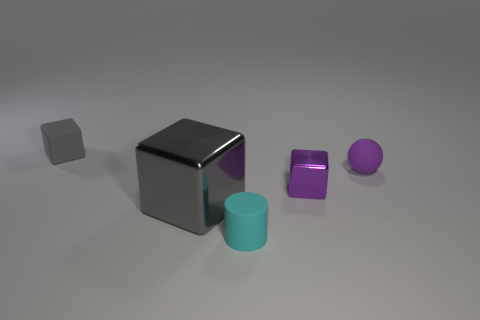Subtract all large metal blocks. How many blocks are left? 2 Subtract all brown cylinders. How many gray cubes are left? 2 Add 2 tiny things. How many objects exist? 7 Subtract all cubes. How many objects are left? 2 Subtract all cyan cylinders. Subtract all tiny purple spheres. How many objects are left? 3 Add 2 small gray blocks. How many small gray blocks are left? 3 Add 3 gray matte blocks. How many gray matte blocks exist? 4 Subtract 0 blue balls. How many objects are left? 5 Subtract all yellow spheres. Subtract all purple cylinders. How many spheres are left? 1 